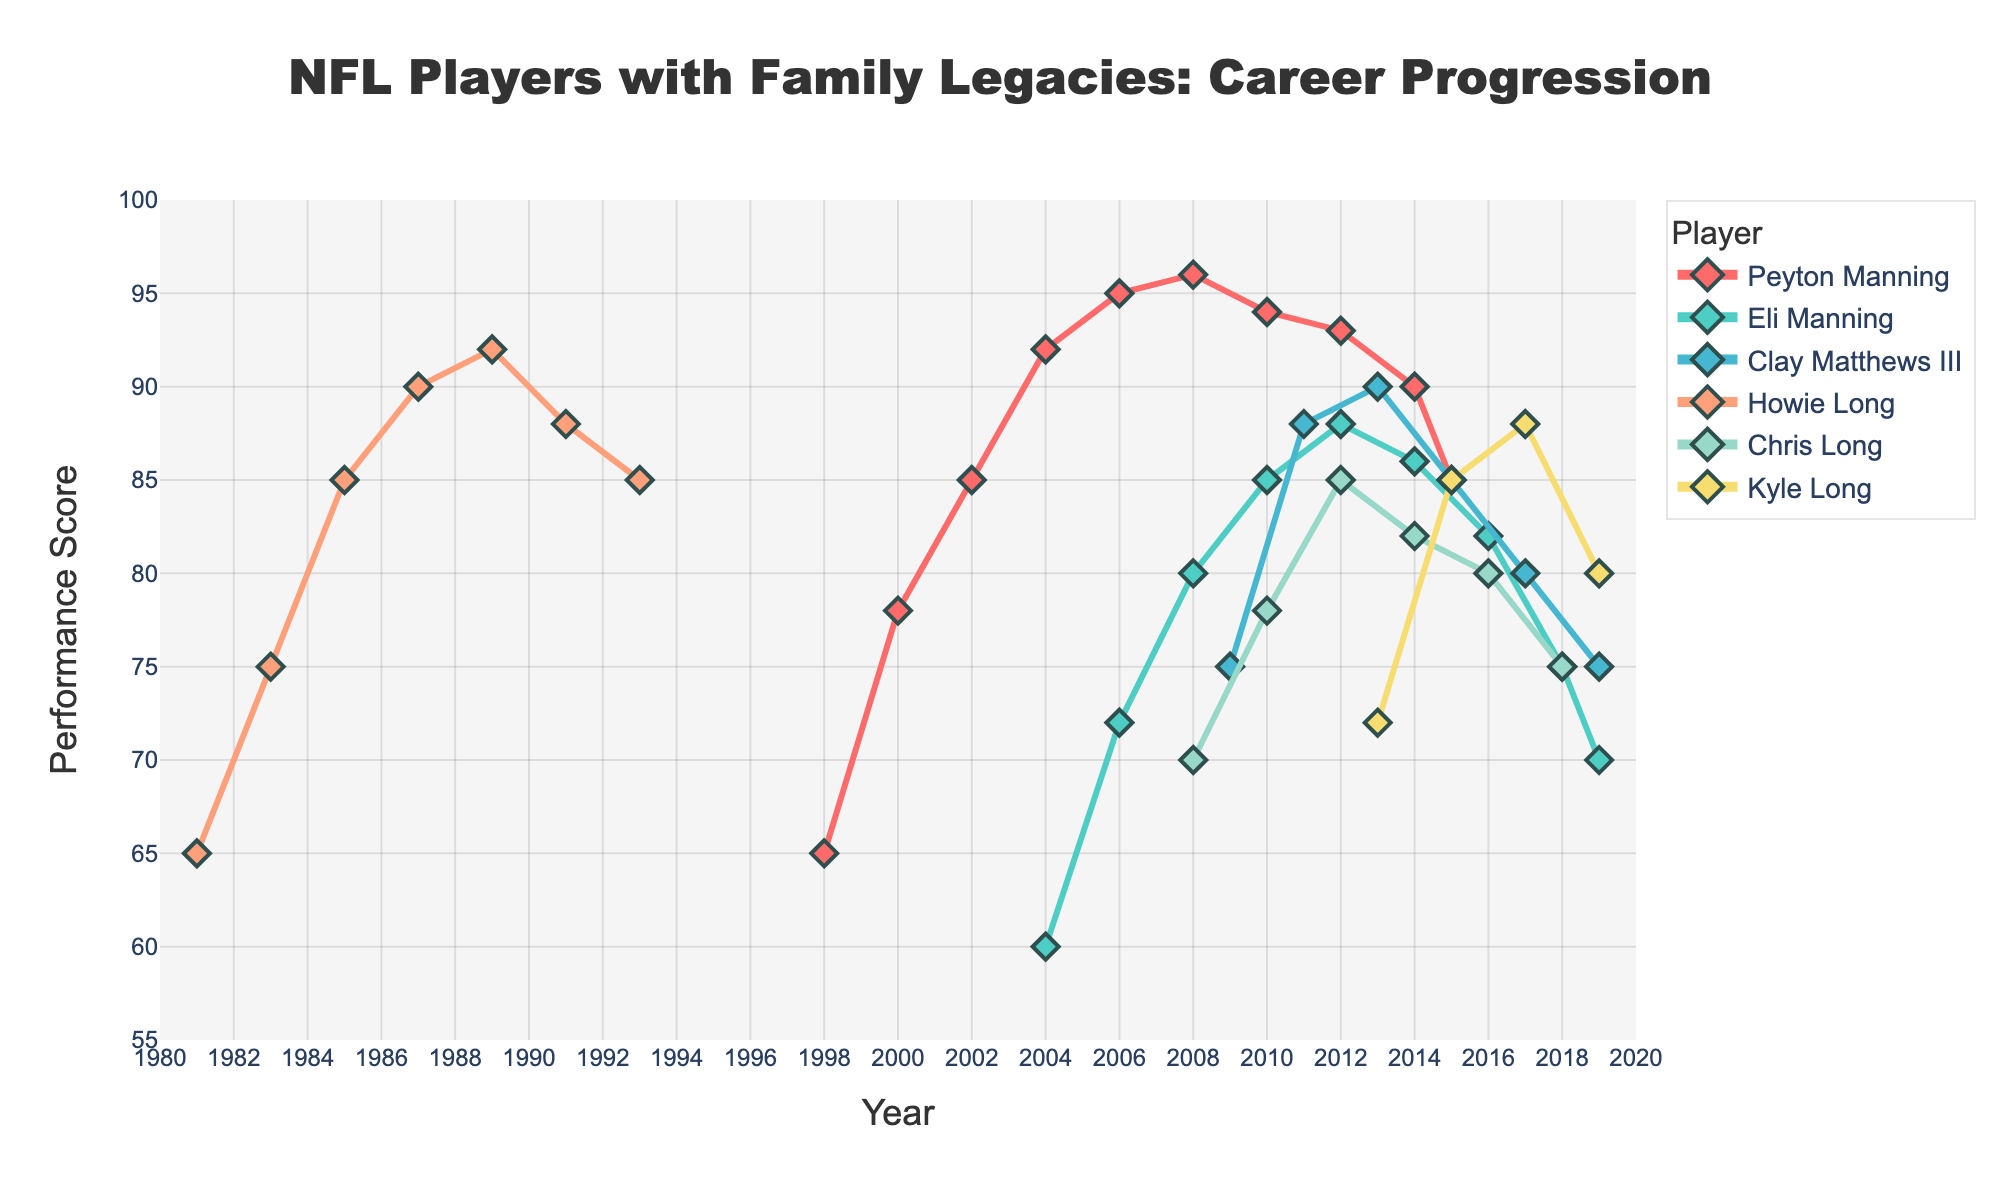Which player started with the highest Performance Score in their rookie year? Look at the Year and Performance Score for each player's earliest recorded year. Peyton Manning started with 65 in 1998, Eli Manning with 60 in 2004, Clay Matthews III with 75 in 2009, Howie Long with 65 in 1981, Chris Long with 70 in 2008, and Kyle Long with 72 in 2013. Clay Matthews III had the highest starting score of 75.
Answer: Clay Matthews III How did Peyton Manning’s performance progression compare to Eli Manning’s from 2004 to 2008? Look at the Performance Scores for both players during the specified years. In 2004, Peyton had 92 while Eli had 60. By 2008, Peyton’s score increased to 96, and Eli’s increased to 80. Peyton's score increased by 4 points, whereas Eli's increased by 20 points. Even though Peyton started higher, Eli had a more significant increase.
Answer: Eli Manning increased more Who had the highest peak Performance Score and what year did it occur? Identify the highest points in the figure and check their corresponding years. Peyton Manning reached 96 in 2008; Howie Long hit 92 in 1989. Peyton's 96 in 2008 is the highest peak Performance Score.
Answer: Peyton Manning in 2008 In which years did both Chris Long and Kyle Long have the same Performance Score, and what was the score? Check the data points for Chris Long and Kyle Long, and match the Performance Scores. In 2008 and 2018, Chris had 70 and 75, while Kyle had 72 and 80. There is no year where they had the same score.
Answer: None Who had a drop in their Performance Score between 2016 and 2018, and by how much did it change? Check the scores for each player between 2016 and 2018. Eli Manning’s score dropped from 82 to 75, Chris Long’s from 80 to 75. Eli’s change was 7 points and Chris’ was 5 points. Eli Manning had the largest drop.
Answer: Eli Manning by 7 points Did any player's Performance Score increase steadily without any drop over their career? Examine the trend lines for each player and check for any drops. Peyton Manning showed slight drops, Eli Manning had drops towards the end, Clay Matthews III showed a drop after 2013, Howie Long had drops after 1989, Chris Long and Kyle Long also showed fluctuations.
Answer: None What was the combined Performance Score of the Long family (Howie, Chris, and Kyle) in 2014? Sum the Performance Scores of Howie Long, Chris Long, and Kyle Long for the year 2014. Howie: (EFI after 1993), Chris: 82, Kyle: 85. Combined score = 82 + 85 = 167.
Answer: 167 Who had the highest Performance Score in 2010 and how much higher was it compared to the other players’ scores? Identify each player's Performance Score for 2010. Peyton Manning had 94, Eli Manning had 85, Clay Matthews III had 88, Howie, Chris, and Kyle Long did not have data for 2010. Peyton had the highest score of 94. The most significant gap was between Peyton and Eli, which is 94 - 85 = 9.
Answer: Peyton Manning, 9 points higher than Eli Which color line represents Clay Matthews III, and what is the visual attribute of his markers? Check the figure’s legend to identify Clay Matthews III's line color. His line is colored blue. The markers are diamond-shaped with a size of 10 and a dark slate grey outline.
Answer: Blue line, diamond-shaped markers What was the trend in Kyle Long’s Performance Score from 2013 to 2019? Look at the points corresponding to Kyle Long in the years 2013, 2015, 2017, and 2019. His scores were 72, 85, 88, and 80 respectively. The trend shows an initial increase from 72 to 88, followed by a decline to 80 by 2019.
Answer: Increase then decrease 